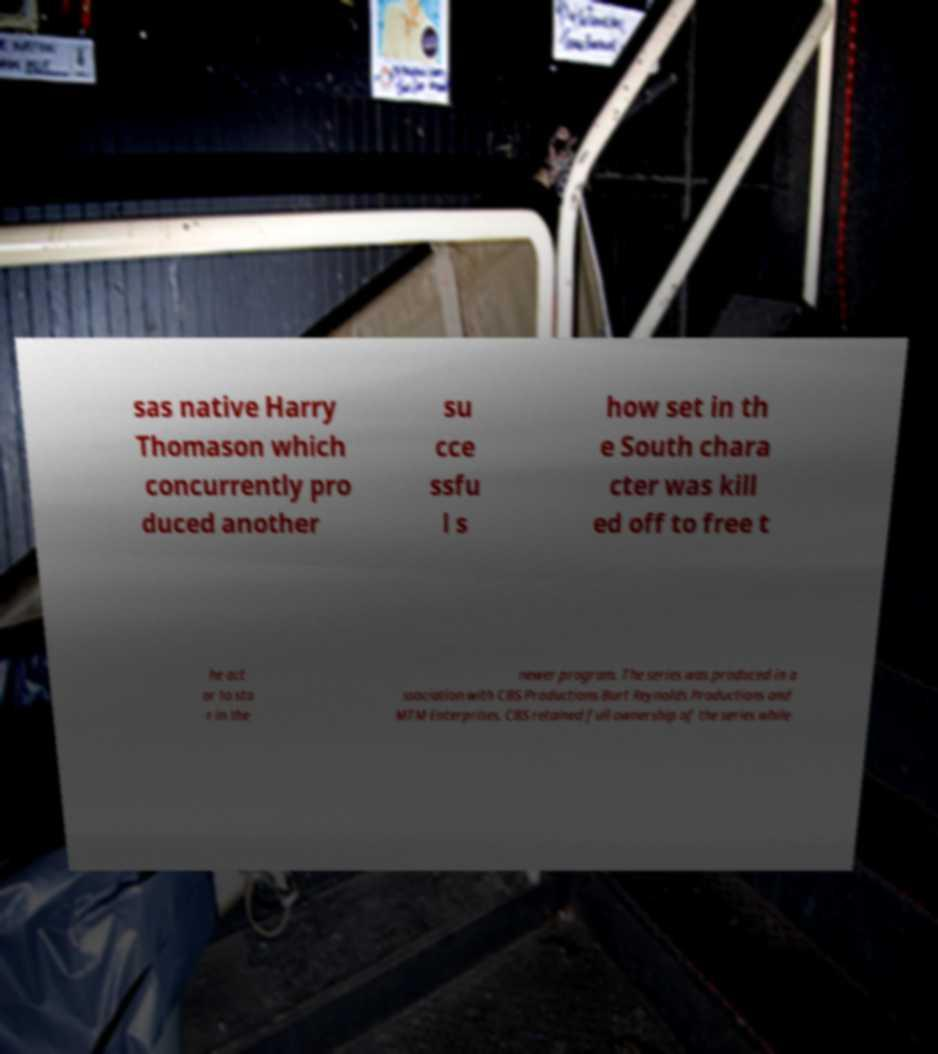Could you assist in decoding the text presented in this image and type it out clearly? sas native Harry Thomason which concurrently pro duced another su cce ssfu l s how set in th e South chara cter was kill ed off to free t he act or to sta r in the newer program. The series was produced in a ssociation with CBS Productions Burt Reynolds Productions and MTM Enterprises. CBS retained full ownership of the series while 